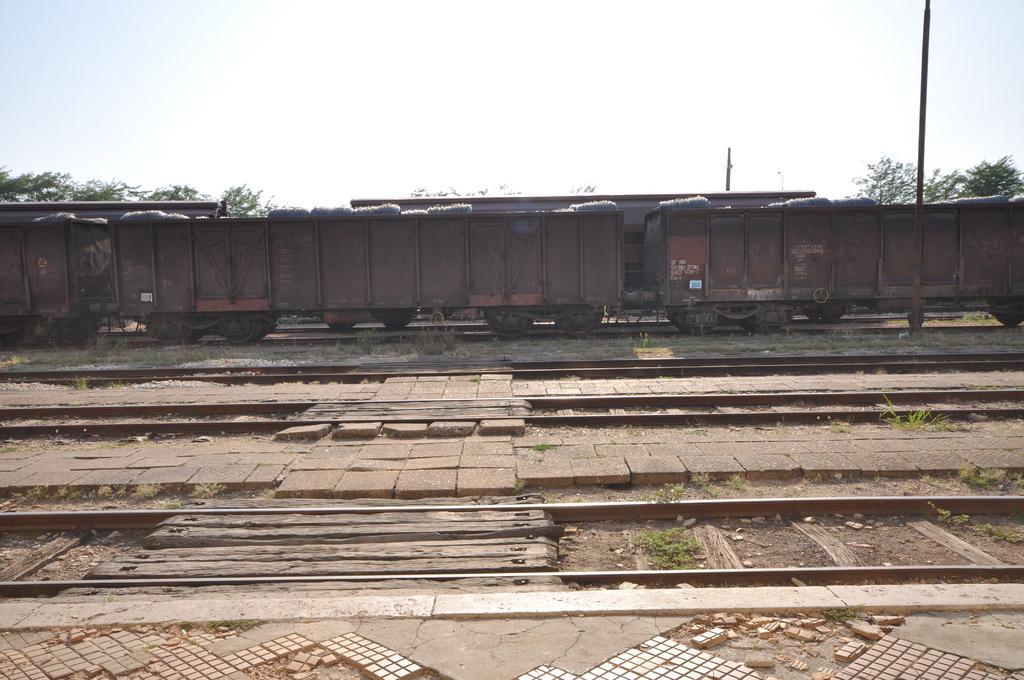Could you give a brief overview of what you see in this image? In this picture we can see a train on the tracks, beside to the tracks we can find few poles and trees. 